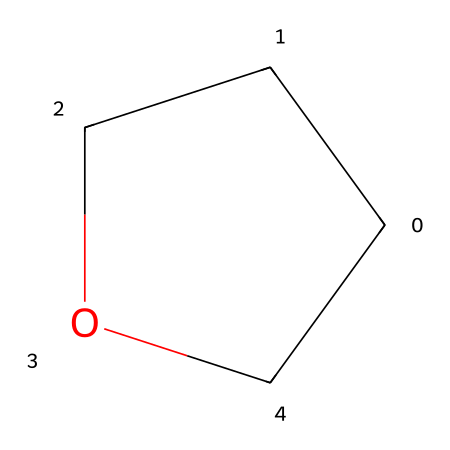How many carbon atoms are in tetrahydrofuran? The chemical structure shows a ring consisting of carbon atoms and one oxygen atom. Counting the carbon atoms gives a total of four.
Answer: four What functional group does tetrahydrofuran belong to? The presence of an ether link (C-O-C) in the structure indicates that tetrahydrofuran is classified as an ether.
Answer: ether What is the molecular formula of tetrahydrofuran? By identifying all the atoms in the structure, we see four carbon atoms, eight hydrogen atoms, and one oxygen atom, leading to the molecular formula C4H8O.
Answer: C4H8O How many bonds are there in the tetrahydrofuran molecule? The structure has six carbon-hydrogen bonds (C-H), four carbon-carbon bonds (C-C), and one carbon-oxygen bond (C-O). Adding these gives a total of eleven bonds in the molecule.
Answer: eleven What is the primary use of tetrahydrofuran? Tetrahydrofuran is primarily used as a solvent in various chemical manufacturing processes, including polymer production and extraction procedures.
Answer: solvent Why is tetrahydrofuran considered a polar aprotic solvent? Tetrahydrofuran is polar due to the electronegative oxygen atom, but it does not have hydrogen attached to the electronegative atom to form strong hydrogen bonds, categorizing it as aprotic.
Answer: polar aprotic What kind of reaction is tetrahydrofuran commonly involved in? Tetrahydrofuran is often employed in nucleophilic substitution reactions due to its ability to dissolve various reactants and facilitate their interaction.
Answer: nucleophilic substitution 